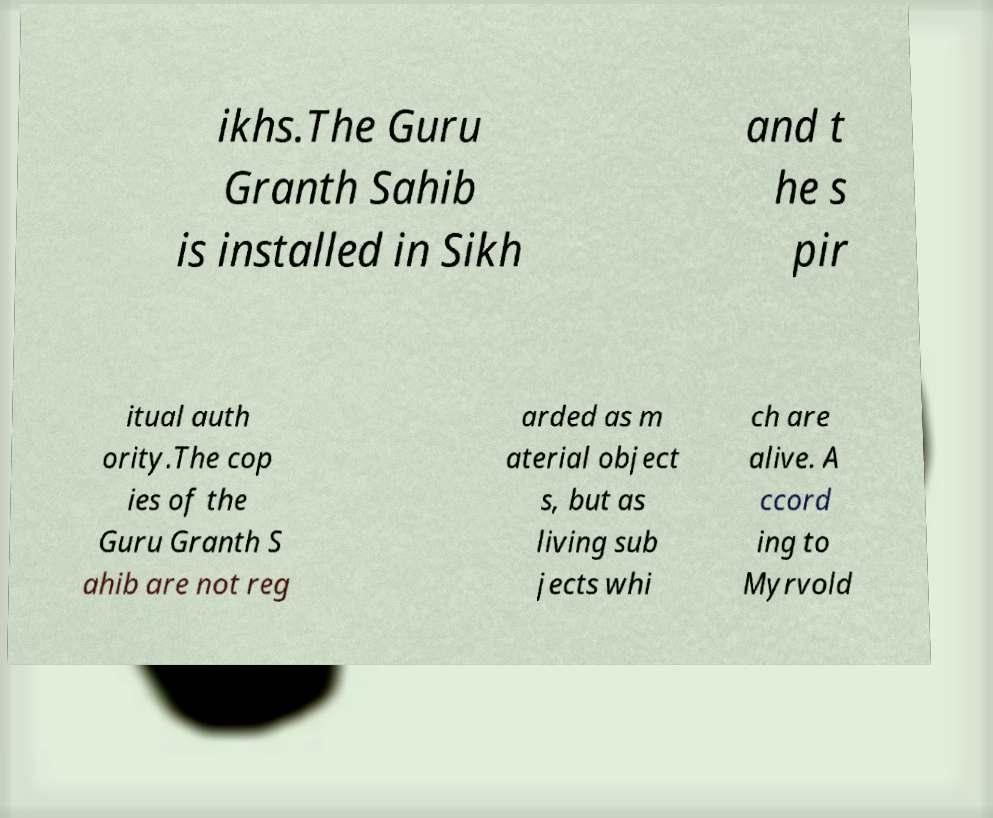Could you assist in decoding the text presented in this image and type it out clearly? ikhs.The Guru Granth Sahib is installed in Sikh and t he s pir itual auth ority.The cop ies of the Guru Granth S ahib are not reg arded as m aterial object s, but as living sub jects whi ch are alive. A ccord ing to Myrvold 